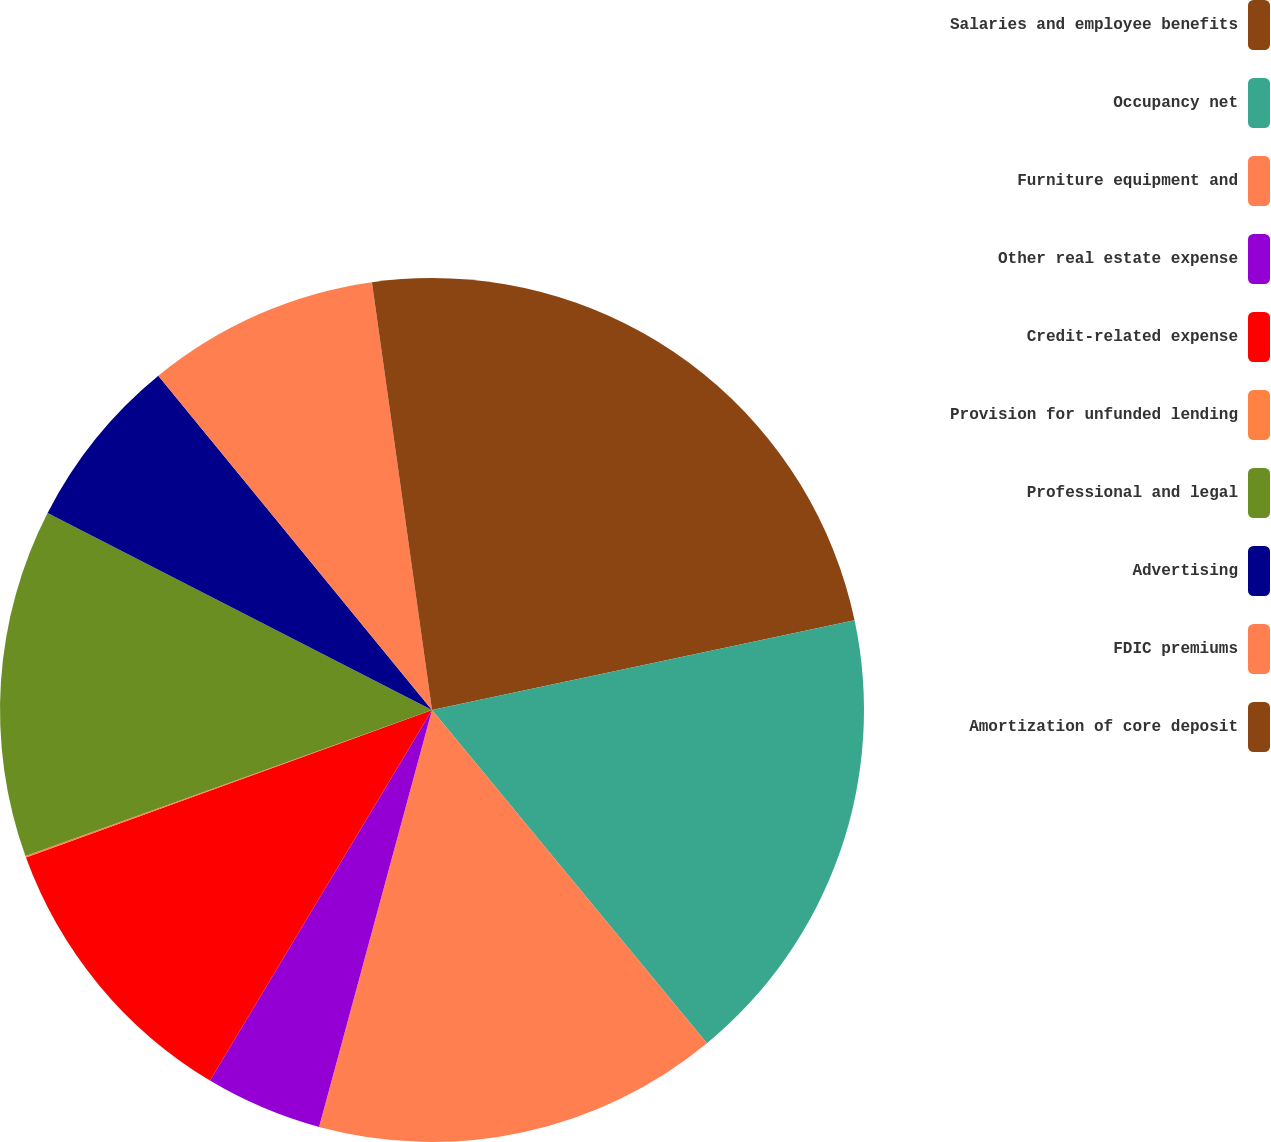Convert chart. <chart><loc_0><loc_0><loc_500><loc_500><pie_chart><fcel>Salaries and employee benefits<fcel>Occupancy net<fcel>Furniture equipment and<fcel>Other real estate expense<fcel>Credit-related expense<fcel>Provision for unfunded lending<fcel>Professional and legal<fcel>Advertising<fcel>FDIC premiums<fcel>Amortization of core deposit<nl><fcel>21.67%<fcel>17.35%<fcel>15.19%<fcel>4.38%<fcel>10.86%<fcel>0.06%<fcel>13.03%<fcel>6.54%<fcel>8.7%<fcel>2.22%<nl></chart> 